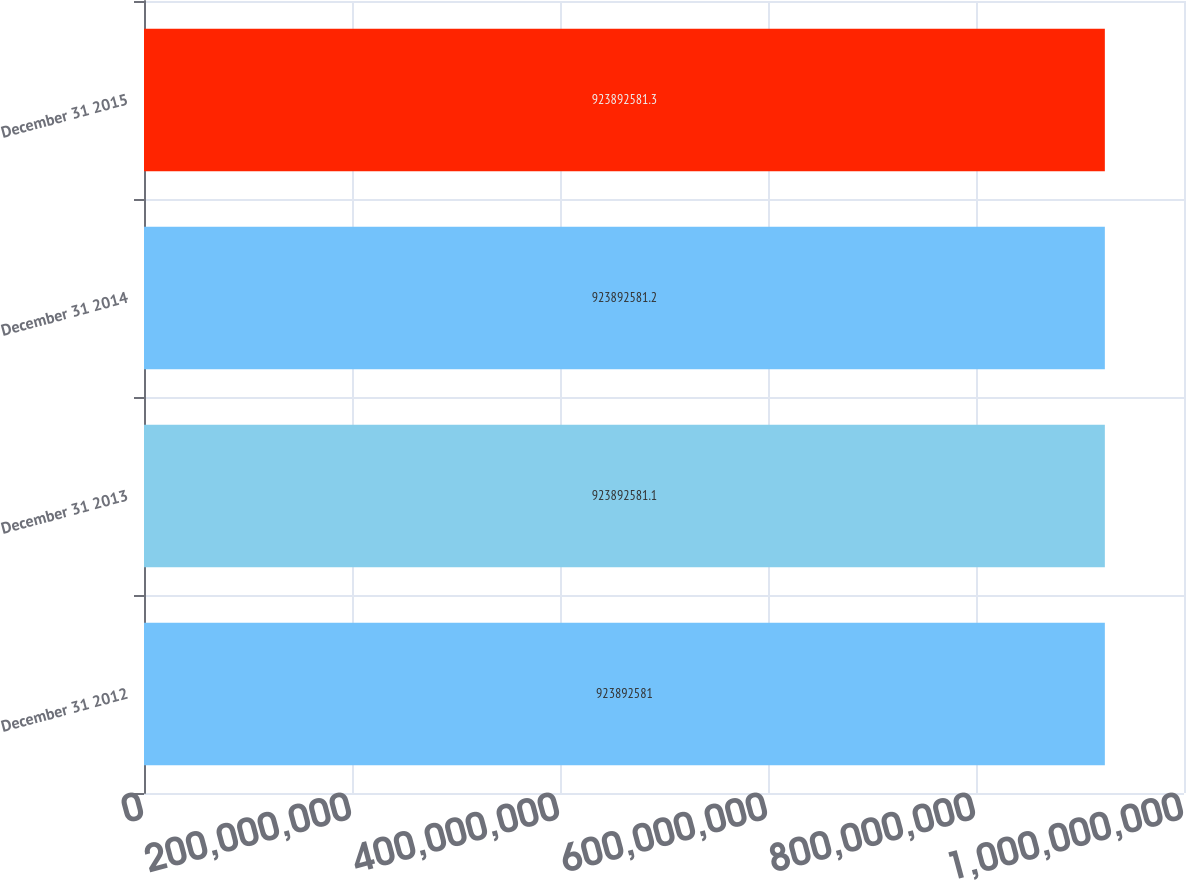Convert chart to OTSL. <chart><loc_0><loc_0><loc_500><loc_500><bar_chart><fcel>December 31 2012<fcel>December 31 2013<fcel>December 31 2014<fcel>December 31 2015<nl><fcel>9.23893e+08<fcel>9.23893e+08<fcel>9.23893e+08<fcel>9.23893e+08<nl></chart> 